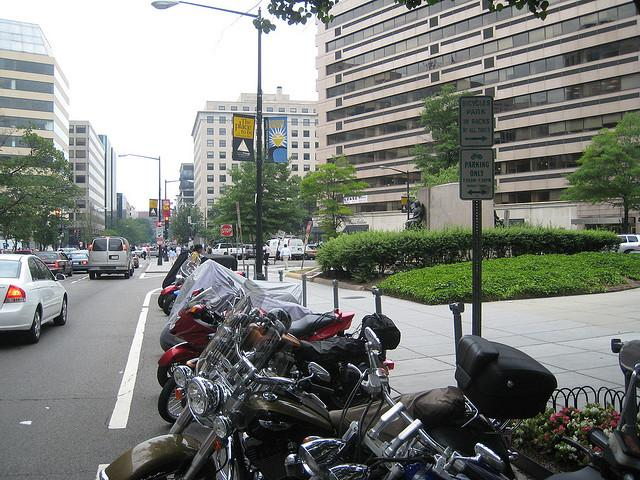What types of people use this part of the street the most? Please explain your reasoning. motorcyclists. The people are motorcyclists. 